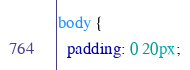Convert code to text. <code><loc_0><loc_0><loc_500><loc_500><_CSS_>body {
  padding: 0 20px;</code> 